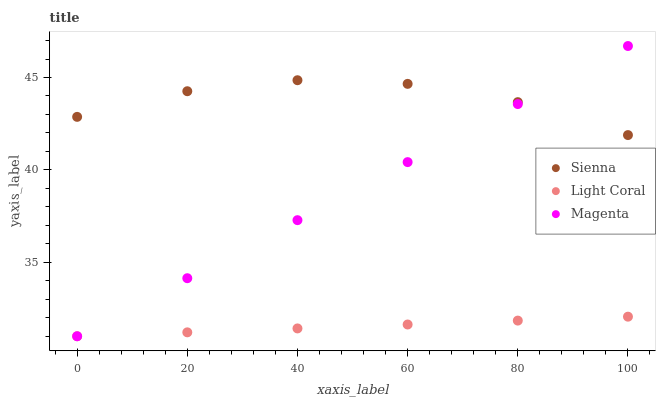Does Light Coral have the minimum area under the curve?
Answer yes or no. Yes. Does Sienna have the maximum area under the curve?
Answer yes or no. Yes. Does Magenta have the minimum area under the curve?
Answer yes or no. No. Does Magenta have the maximum area under the curve?
Answer yes or no. No. Is Light Coral the smoothest?
Answer yes or no. Yes. Is Sienna the roughest?
Answer yes or no. Yes. Is Magenta the smoothest?
Answer yes or no. No. Is Magenta the roughest?
Answer yes or no. No. Does Light Coral have the lowest value?
Answer yes or no. Yes. Does Magenta have the highest value?
Answer yes or no. Yes. Does Light Coral have the highest value?
Answer yes or no. No. Is Light Coral less than Sienna?
Answer yes or no. Yes. Is Sienna greater than Light Coral?
Answer yes or no. Yes. Does Magenta intersect Light Coral?
Answer yes or no. Yes. Is Magenta less than Light Coral?
Answer yes or no. No. Is Magenta greater than Light Coral?
Answer yes or no. No. Does Light Coral intersect Sienna?
Answer yes or no. No. 